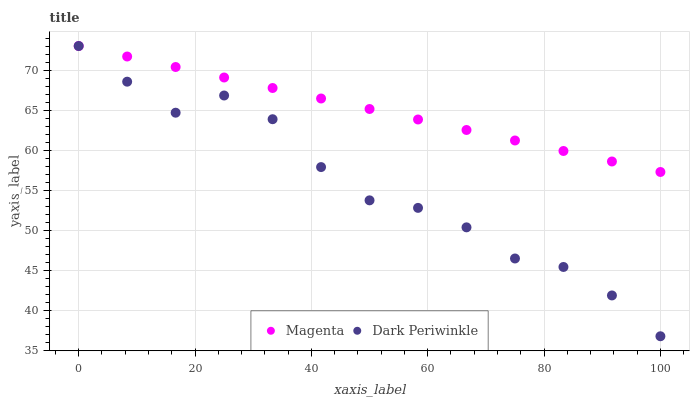Does Dark Periwinkle have the minimum area under the curve?
Answer yes or no. Yes. Does Magenta have the maximum area under the curve?
Answer yes or no. Yes. Does Dark Periwinkle have the maximum area under the curve?
Answer yes or no. No. Is Magenta the smoothest?
Answer yes or no. Yes. Is Dark Periwinkle the roughest?
Answer yes or no. Yes. Is Dark Periwinkle the smoothest?
Answer yes or no. No. Does Dark Periwinkle have the lowest value?
Answer yes or no. Yes. Does Dark Periwinkle have the highest value?
Answer yes or no. Yes. Does Magenta intersect Dark Periwinkle?
Answer yes or no. Yes. Is Magenta less than Dark Periwinkle?
Answer yes or no. No. Is Magenta greater than Dark Periwinkle?
Answer yes or no. No. 